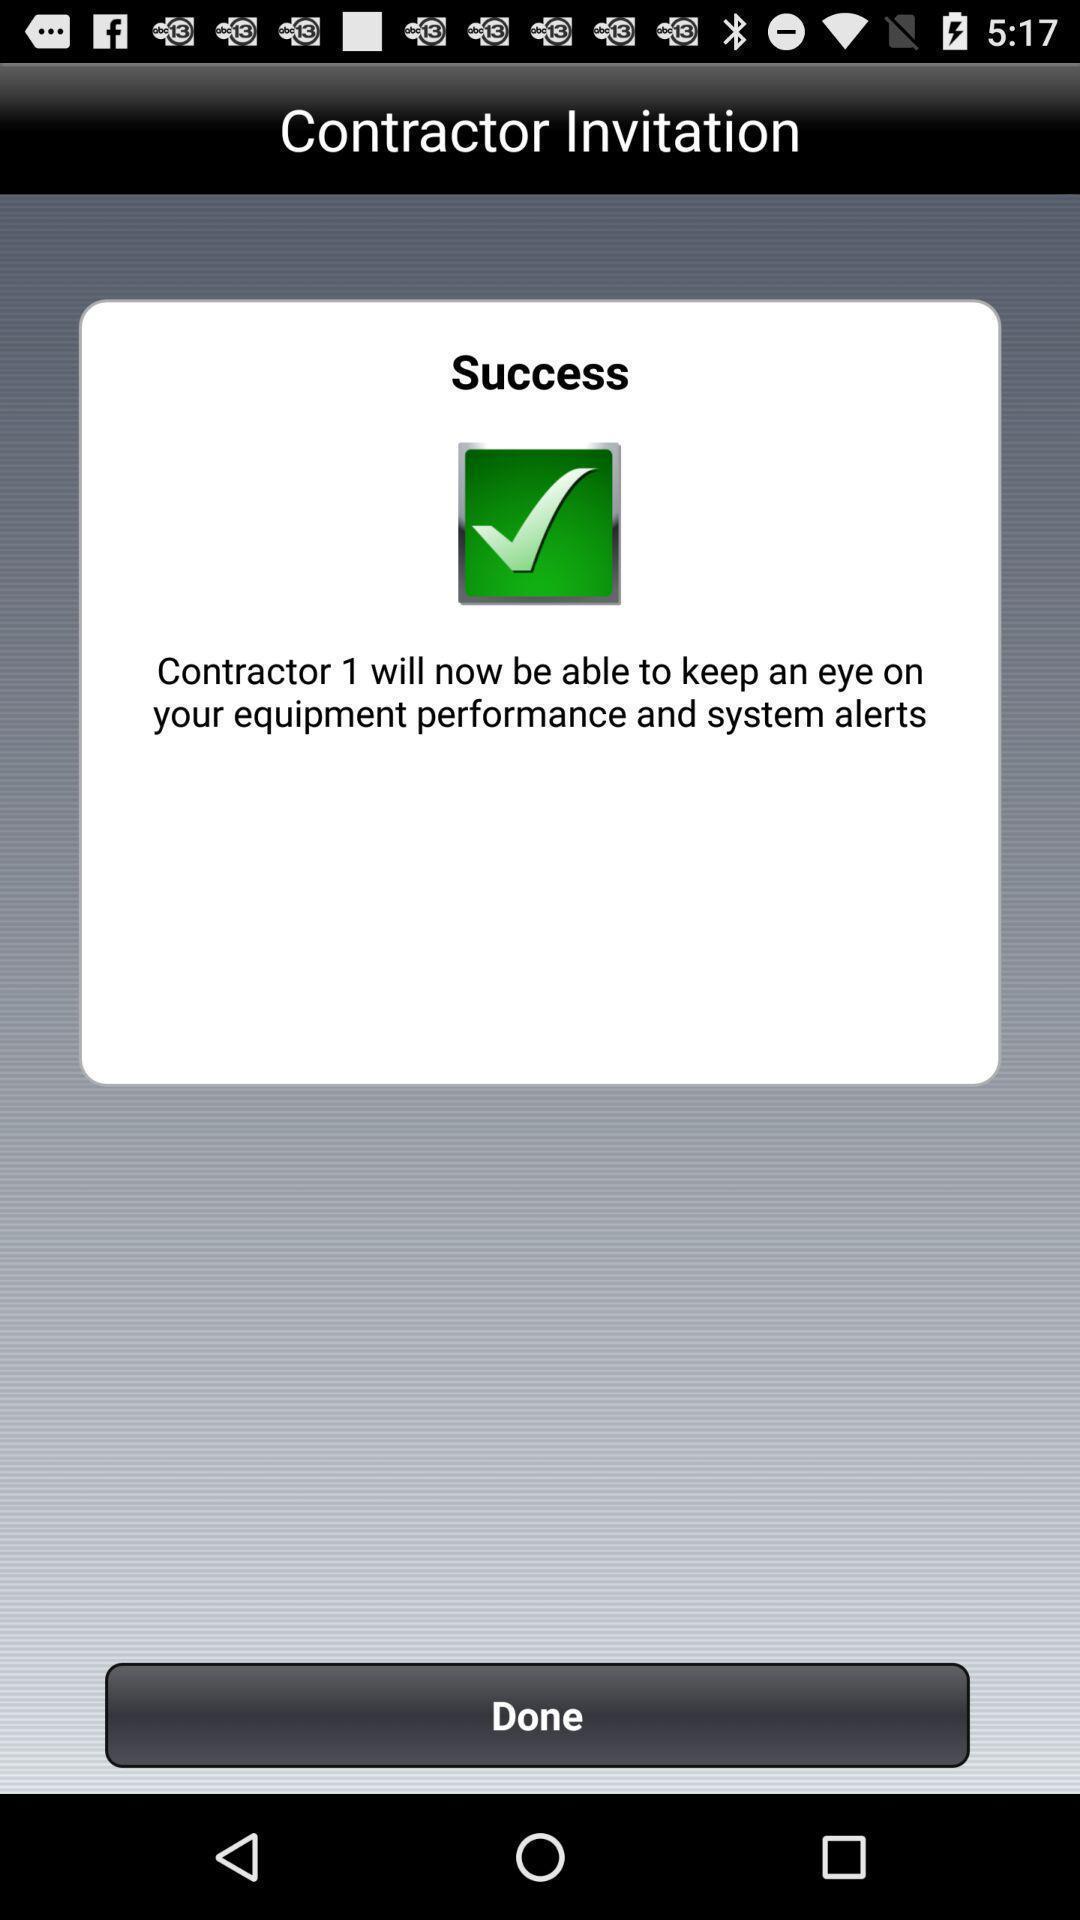Give me a narrative description of this picture. Screen shows invitation alerts details. 